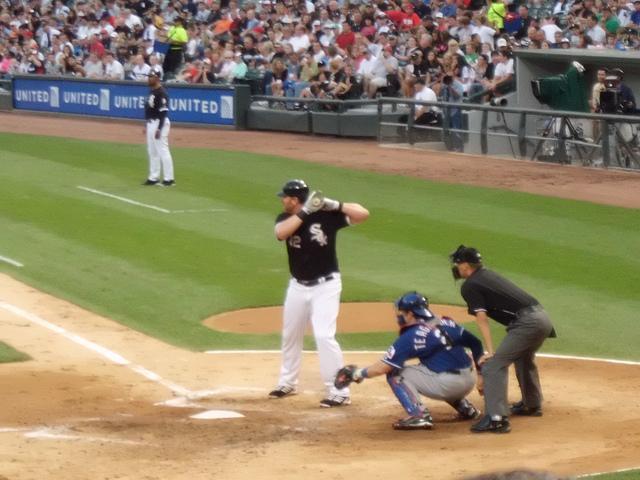How many people are visible?
Give a very brief answer. 5. How many giraffes are in the picture?
Give a very brief answer. 0. 